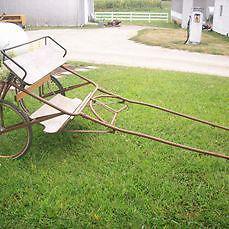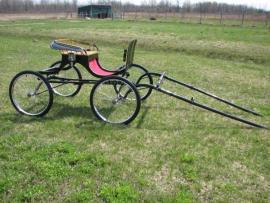The first image is the image on the left, the second image is the image on the right. Evaluate the accuracy of this statement regarding the images: "A two-wheeled black cart is displayed in a side view on grass, with its leads touching the ground.". Is it true? Answer yes or no. No. The first image is the image on the left, the second image is the image on the right. Considering the images on both sides, is "One of the carriages is red and black." valid? Answer yes or no. Yes. 